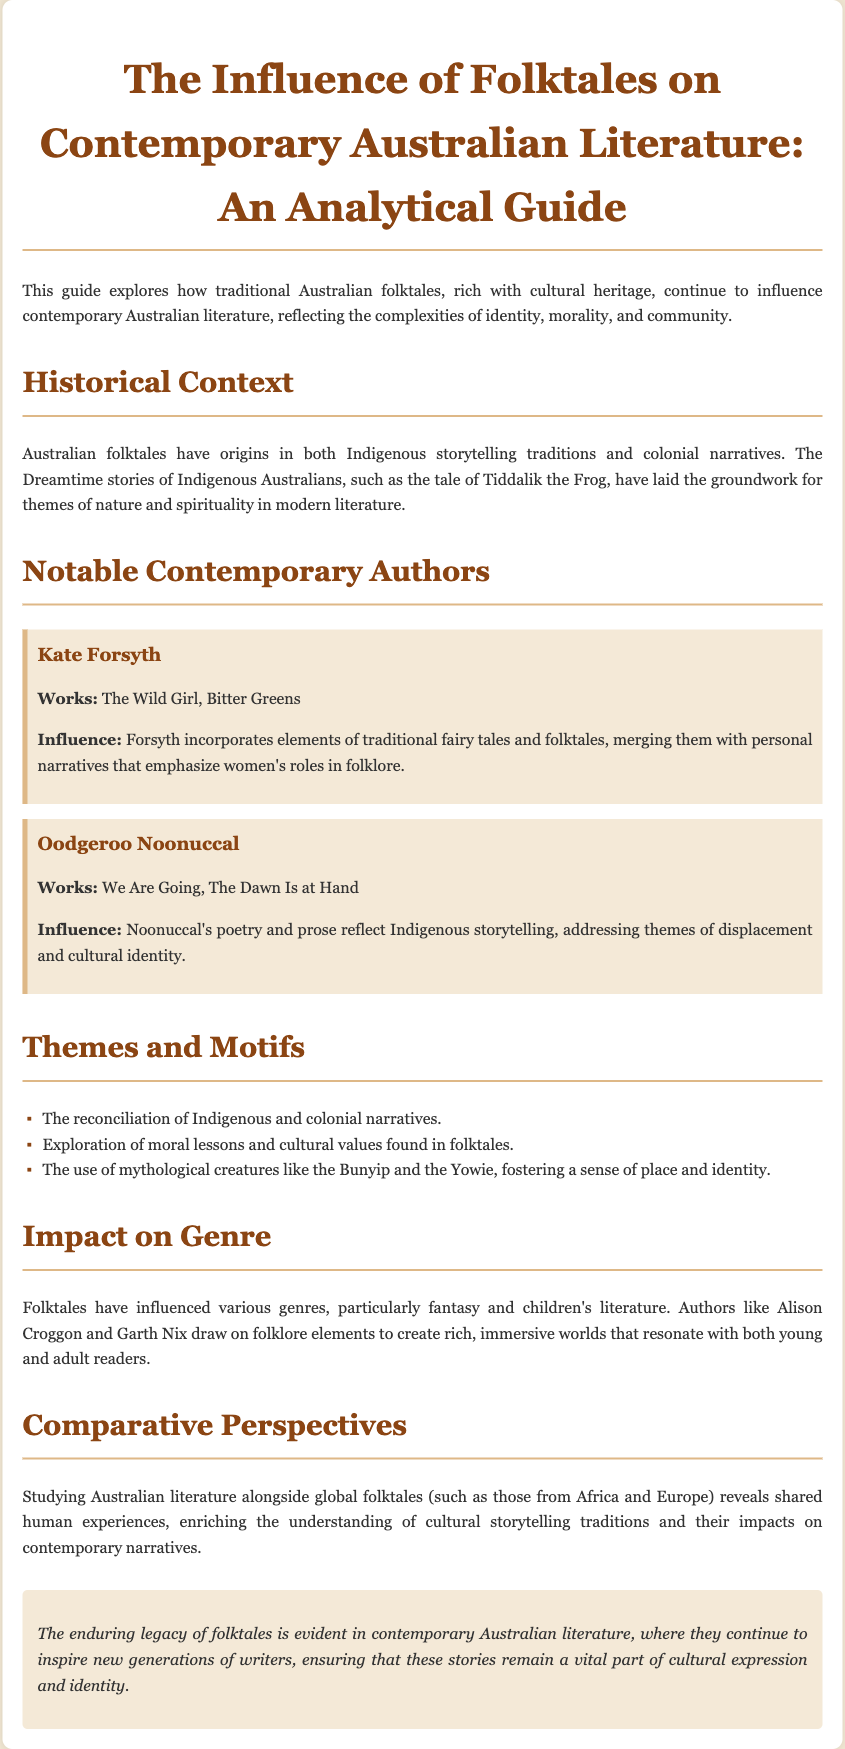What is the title of the guide? The title of the guide is presented prominently at the top of the document, which states its main focus.
Answer: The Influence of Folktales on Contemporary Australian Literature: An Analytical Guide Who is the author discussed that wrote "We Are Going"? This author is associated with Indigenous poetry and prose, highlighting themes of displacement.
Answer: Oodgeroo Noonuccal What are the two notable works of Kate Forsyth mentioned? The document lists these works under Forsyth's profile to illustrate her contributions to literature.
Answer: The Wild Girl, Bitter Greens What major themes do Indigenous and colonial narratives reconcile? The document outlines overarching themes that can be seen in the storytelling traditions represented in the literature.
Answer: Reconciliation of Indigenous and colonial narratives Which mythological creature is mentioned in the context of fostering a sense of place? The document provides an example of a mythical figure from Australian folklore that resonates with cultural identity.
Answer: Bunyip What genre has been most influenced by folktales according to the guide? The guide discusses how certain types of literature have particularly drawn from folktale traditions.
Answer: Fantasy and children's literature What is one impact of studying Australian literature alongside global folktales? The guide indicates the benefits of comparative literature, emphasizing shared experiences across cultures.
Answer: Enriching the understanding of cultural storytelling traditions 